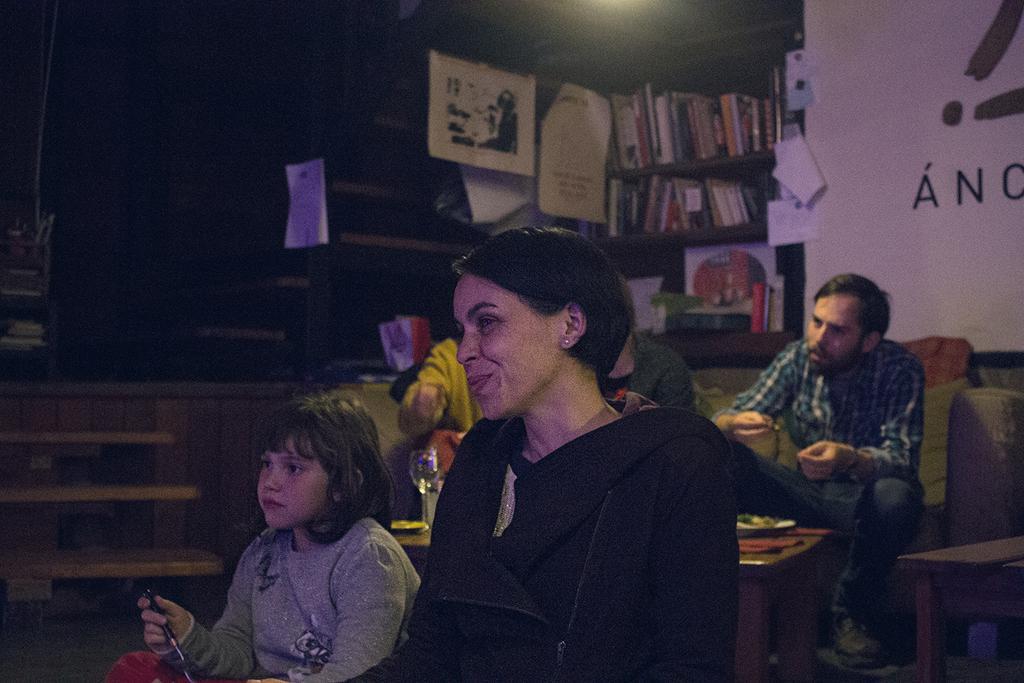How would you summarize this image in a sentence or two? In this image there are a few people sitting with a smile on their face and looking at the left side of the image, in between them there is a table with some stuff on it. In the background there is a rack stored with books and a wall. 